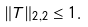Convert formula to latex. <formula><loc_0><loc_0><loc_500><loc_500>\| T \| _ { 2 , 2 } \leq 1 .</formula> 